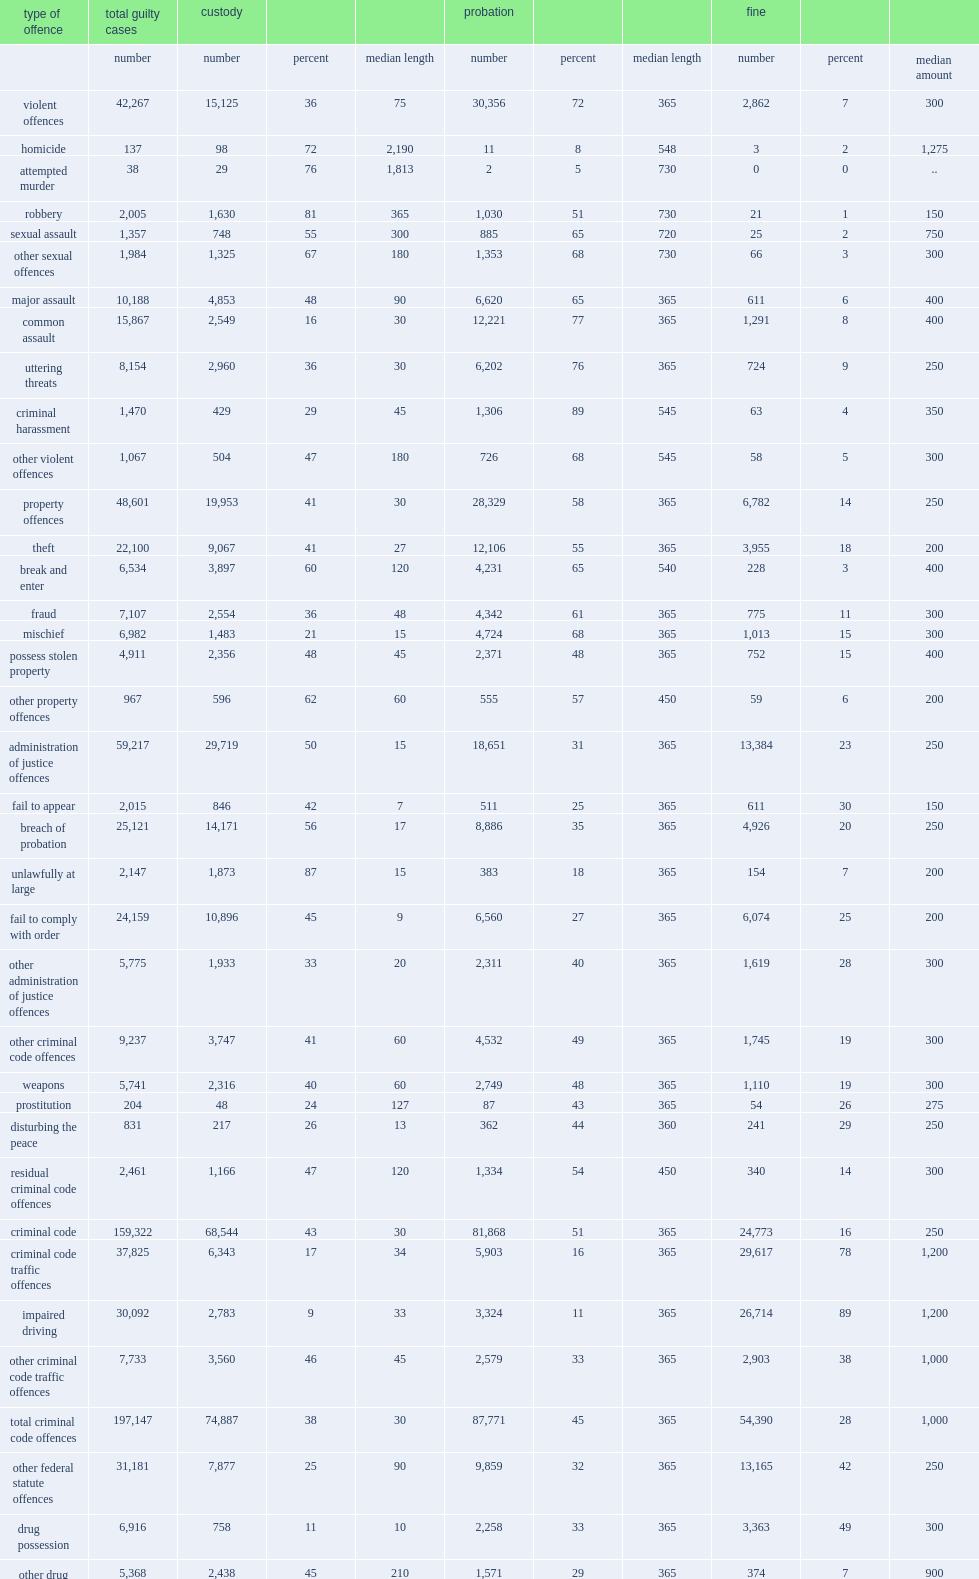What is the proportion of probation in all criminal cases in 2013 / 2014? 43.0. What is the proportion of custodial sentences in all criminal cases in 2013 / 2014? 36.0. 